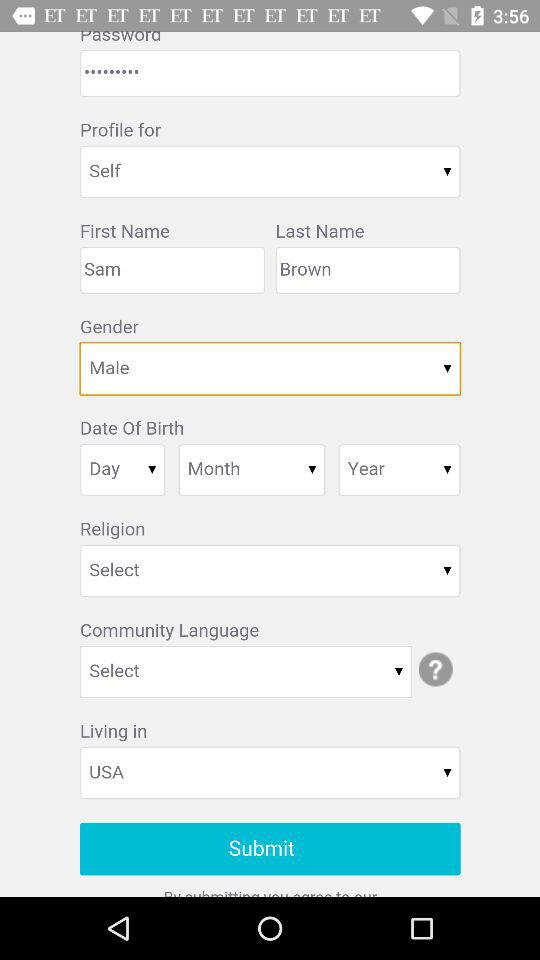What is the user's last name? The user's last name is Brown. 